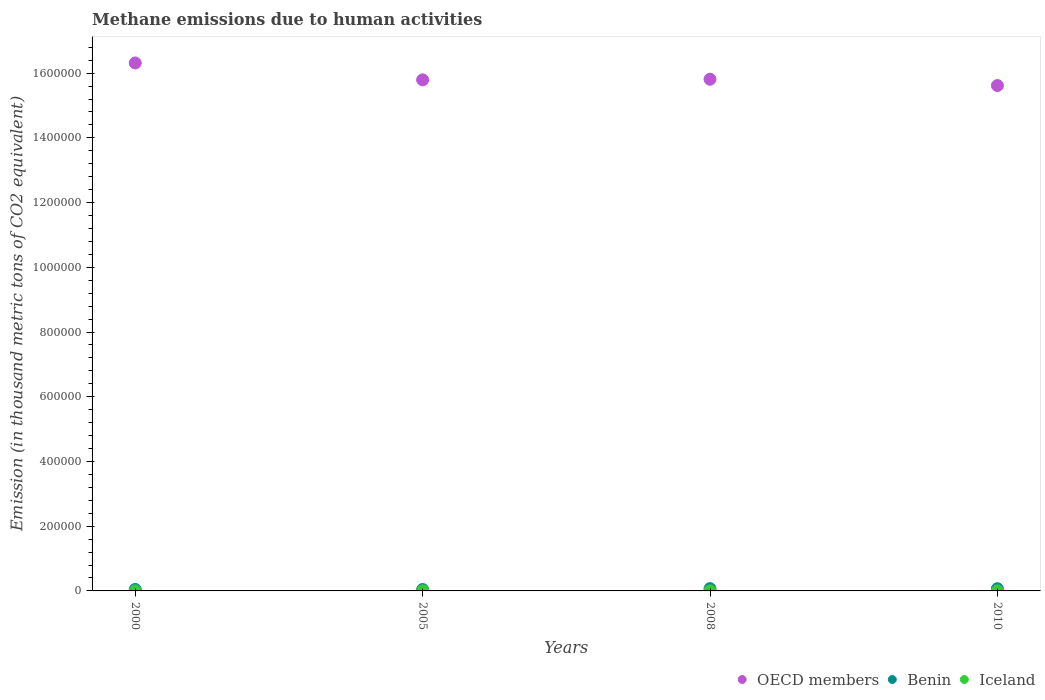Is the number of dotlines equal to the number of legend labels?
Your answer should be compact. Yes. What is the amount of methane emitted in OECD members in 2008?
Your answer should be compact. 1.58e+06. Across all years, what is the maximum amount of methane emitted in OECD members?
Your answer should be compact. 1.63e+06. Across all years, what is the minimum amount of methane emitted in OECD members?
Provide a succinct answer. 1.56e+06. In which year was the amount of methane emitted in OECD members minimum?
Provide a succinct answer. 2010. What is the total amount of methane emitted in Iceland in the graph?
Provide a succinct answer. 1422.9. What is the difference between the amount of methane emitted in Iceland in 2005 and that in 2008?
Give a very brief answer. -31.3. What is the difference between the amount of methane emitted in OECD members in 2005 and the amount of methane emitted in Benin in 2010?
Ensure brevity in your answer.  1.57e+06. What is the average amount of methane emitted in Iceland per year?
Make the answer very short. 355.72. In the year 2010, what is the difference between the amount of methane emitted in Iceland and amount of methane emitted in Benin?
Your answer should be compact. -6462.3. What is the ratio of the amount of methane emitted in OECD members in 2008 to that in 2010?
Ensure brevity in your answer.  1.01. Is the amount of methane emitted in OECD members in 2008 less than that in 2010?
Offer a very short reply. No. What is the difference between the highest and the second highest amount of methane emitted in OECD members?
Provide a succinct answer. 5.02e+04. What is the difference between the highest and the lowest amount of methane emitted in Iceland?
Provide a short and direct response. 47.4. Is the sum of the amount of methane emitted in Benin in 2000 and 2005 greater than the maximum amount of methane emitted in OECD members across all years?
Your answer should be very brief. No. Does the amount of methane emitted in OECD members monotonically increase over the years?
Make the answer very short. No. Is the amount of methane emitted in Iceland strictly greater than the amount of methane emitted in Benin over the years?
Offer a terse response. No. How many dotlines are there?
Provide a succinct answer. 3. What is the difference between two consecutive major ticks on the Y-axis?
Make the answer very short. 2.00e+05. Does the graph contain grids?
Offer a terse response. No. How many legend labels are there?
Offer a very short reply. 3. What is the title of the graph?
Your answer should be very brief. Methane emissions due to human activities. What is the label or title of the Y-axis?
Your answer should be very brief. Emission (in thousand metric tons of CO2 equivalent). What is the Emission (in thousand metric tons of CO2 equivalent) in OECD members in 2000?
Offer a very short reply. 1.63e+06. What is the Emission (in thousand metric tons of CO2 equivalent) in Benin in 2000?
Give a very brief answer. 4503.8. What is the Emission (in thousand metric tons of CO2 equivalent) in Iceland in 2000?
Ensure brevity in your answer.  336.5. What is the Emission (in thousand metric tons of CO2 equivalent) in OECD members in 2005?
Give a very brief answer. 1.58e+06. What is the Emission (in thousand metric tons of CO2 equivalent) of Benin in 2005?
Provide a succinct answer. 4377.3. What is the Emission (in thousand metric tons of CO2 equivalent) in Iceland in 2005?
Your response must be concise. 335.9. What is the Emission (in thousand metric tons of CO2 equivalent) of OECD members in 2008?
Offer a very short reply. 1.58e+06. What is the Emission (in thousand metric tons of CO2 equivalent) in Benin in 2008?
Ensure brevity in your answer.  7086.6. What is the Emission (in thousand metric tons of CO2 equivalent) in Iceland in 2008?
Your answer should be compact. 367.2. What is the Emission (in thousand metric tons of CO2 equivalent) in OECD members in 2010?
Your answer should be compact. 1.56e+06. What is the Emission (in thousand metric tons of CO2 equivalent) in Benin in 2010?
Make the answer very short. 6845.6. What is the Emission (in thousand metric tons of CO2 equivalent) of Iceland in 2010?
Offer a terse response. 383.3. Across all years, what is the maximum Emission (in thousand metric tons of CO2 equivalent) in OECD members?
Provide a short and direct response. 1.63e+06. Across all years, what is the maximum Emission (in thousand metric tons of CO2 equivalent) of Benin?
Your answer should be compact. 7086.6. Across all years, what is the maximum Emission (in thousand metric tons of CO2 equivalent) in Iceland?
Give a very brief answer. 383.3. Across all years, what is the minimum Emission (in thousand metric tons of CO2 equivalent) of OECD members?
Offer a very short reply. 1.56e+06. Across all years, what is the minimum Emission (in thousand metric tons of CO2 equivalent) in Benin?
Keep it short and to the point. 4377.3. Across all years, what is the minimum Emission (in thousand metric tons of CO2 equivalent) in Iceland?
Provide a short and direct response. 335.9. What is the total Emission (in thousand metric tons of CO2 equivalent) of OECD members in the graph?
Keep it short and to the point. 6.35e+06. What is the total Emission (in thousand metric tons of CO2 equivalent) of Benin in the graph?
Offer a terse response. 2.28e+04. What is the total Emission (in thousand metric tons of CO2 equivalent) of Iceland in the graph?
Your answer should be compact. 1422.9. What is the difference between the Emission (in thousand metric tons of CO2 equivalent) in OECD members in 2000 and that in 2005?
Offer a terse response. 5.21e+04. What is the difference between the Emission (in thousand metric tons of CO2 equivalent) of Benin in 2000 and that in 2005?
Provide a short and direct response. 126.5. What is the difference between the Emission (in thousand metric tons of CO2 equivalent) in OECD members in 2000 and that in 2008?
Your answer should be very brief. 5.02e+04. What is the difference between the Emission (in thousand metric tons of CO2 equivalent) of Benin in 2000 and that in 2008?
Make the answer very short. -2582.8. What is the difference between the Emission (in thousand metric tons of CO2 equivalent) in Iceland in 2000 and that in 2008?
Your answer should be very brief. -30.7. What is the difference between the Emission (in thousand metric tons of CO2 equivalent) in OECD members in 2000 and that in 2010?
Keep it short and to the point. 6.98e+04. What is the difference between the Emission (in thousand metric tons of CO2 equivalent) of Benin in 2000 and that in 2010?
Ensure brevity in your answer.  -2341.8. What is the difference between the Emission (in thousand metric tons of CO2 equivalent) in Iceland in 2000 and that in 2010?
Offer a very short reply. -46.8. What is the difference between the Emission (in thousand metric tons of CO2 equivalent) in OECD members in 2005 and that in 2008?
Provide a short and direct response. -1871.6. What is the difference between the Emission (in thousand metric tons of CO2 equivalent) in Benin in 2005 and that in 2008?
Your response must be concise. -2709.3. What is the difference between the Emission (in thousand metric tons of CO2 equivalent) of Iceland in 2005 and that in 2008?
Your answer should be compact. -31.3. What is the difference between the Emission (in thousand metric tons of CO2 equivalent) of OECD members in 2005 and that in 2010?
Provide a succinct answer. 1.77e+04. What is the difference between the Emission (in thousand metric tons of CO2 equivalent) of Benin in 2005 and that in 2010?
Offer a very short reply. -2468.3. What is the difference between the Emission (in thousand metric tons of CO2 equivalent) in Iceland in 2005 and that in 2010?
Give a very brief answer. -47.4. What is the difference between the Emission (in thousand metric tons of CO2 equivalent) of OECD members in 2008 and that in 2010?
Ensure brevity in your answer.  1.96e+04. What is the difference between the Emission (in thousand metric tons of CO2 equivalent) in Benin in 2008 and that in 2010?
Your answer should be very brief. 241. What is the difference between the Emission (in thousand metric tons of CO2 equivalent) in Iceland in 2008 and that in 2010?
Make the answer very short. -16.1. What is the difference between the Emission (in thousand metric tons of CO2 equivalent) in OECD members in 2000 and the Emission (in thousand metric tons of CO2 equivalent) in Benin in 2005?
Give a very brief answer. 1.63e+06. What is the difference between the Emission (in thousand metric tons of CO2 equivalent) in OECD members in 2000 and the Emission (in thousand metric tons of CO2 equivalent) in Iceland in 2005?
Keep it short and to the point. 1.63e+06. What is the difference between the Emission (in thousand metric tons of CO2 equivalent) in Benin in 2000 and the Emission (in thousand metric tons of CO2 equivalent) in Iceland in 2005?
Offer a very short reply. 4167.9. What is the difference between the Emission (in thousand metric tons of CO2 equivalent) of OECD members in 2000 and the Emission (in thousand metric tons of CO2 equivalent) of Benin in 2008?
Your response must be concise. 1.62e+06. What is the difference between the Emission (in thousand metric tons of CO2 equivalent) of OECD members in 2000 and the Emission (in thousand metric tons of CO2 equivalent) of Iceland in 2008?
Offer a terse response. 1.63e+06. What is the difference between the Emission (in thousand metric tons of CO2 equivalent) of Benin in 2000 and the Emission (in thousand metric tons of CO2 equivalent) of Iceland in 2008?
Provide a short and direct response. 4136.6. What is the difference between the Emission (in thousand metric tons of CO2 equivalent) in OECD members in 2000 and the Emission (in thousand metric tons of CO2 equivalent) in Benin in 2010?
Offer a very short reply. 1.62e+06. What is the difference between the Emission (in thousand metric tons of CO2 equivalent) of OECD members in 2000 and the Emission (in thousand metric tons of CO2 equivalent) of Iceland in 2010?
Your response must be concise. 1.63e+06. What is the difference between the Emission (in thousand metric tons of CO2 equivalent) in Benin in 2000 and the Emission (in thousand metric tons of CO2 equivalent) in Iceland in 2010?
Give a very brief answer. 4120.5. What is the difference between the Emission (in thousand metric tons of CO2 equivalent) in OECD members in 2005 and the Emission (in thousand metric tons of CO2 equivalent) in Benin in 2008?
Keep it short and to the point. 1.57e+06. What is the difference between the Emission (in thousand metric tons of CO2 equivalent) of OECD members in 2005 and the Emission (in thousand metric tons of CO2 equivalent) of Iceland in 2008?
Offer a terse response. 1.58e+06. What is the difference between the Emission (in thousand metric tons of CO2 equivalent) of Benin in 2005 and the Emission (in thousand metric tons of CO2 equivalent) of Iceland in 2008?
Your response must be concise. 4010.1. What is the difference between the Emission (in thousand metric tons of CO2 equivalent) of OECD members in 2005 and the Emission (in thousand metric tons of CO2 equivalent) of Benin in 2010?
Your answer should be very brief. 1.57e+06. What is the difference between the Emission (in thousand metric tons of CO2 equivalent) in OECD members in 2005 and the Emission (in thousand metric tons of CO2 equivalent) in Iceland in 2010?
Offer a terse response. 1.58e+06. What is the difference between the Emission (in thousand metric tons of CO2 equivalent) of Benin in 2005 and the Emission (in thousand metric tons of CO2 equivalent) of Iceland in 2010?
Provide a succinct answer. 3994. What is the difference between the Emission (in thousand metric tons of CO2 equivalent) in OECD members in 2008 and the Emission (in thousand metric tons of CO2 equivalent) in Benin in 2010?
Your answer should be very brief. 1.57e+06. What is the difference between the Emission (in thousand metric tons of CO2 equivalent) of OECD members in 2008 and the Emission (in thousand metric tons of CO2 equivalent) of Iceland in 2010?
Your answer should be compact. 1.58e+06. What is the difference between the Emission (in thousand metric tons of CO2 equivalent) in Benin in 2008 and the Emission (in thousand metric tons of CO2 equivalent) in Iceland in 2010?
Give a very brief answer. 6703.3. What is the average Emission (in thousand metric tons of CO2 equivalent) of OECD members per year?
Provide a succinct answer. 1.59e+06. What is the average Emission (in thousand metric tons of CO2 equivalent) of Benin per year?
Ensure brevity in your answer.  5703.32. What is the average Emission (in thousand metric tons of CO2 equivalent) in Iceland per year?
Provide a short and direct response. 355.73. In the year 2000, what is the difference between the Emission (in thousand metric tons of CO2 equivalent) of OECD members and Emission (in thousand metric tons of CO2 equivalent) of Benin?
Offer a very short reply. 1.63e+06. In the year 2000, what is the difference between the Emission (in thousand metric tons of CO2 equivalent) of OECD members and Emission (in thousand metric tons of CO2 equivalent) of Iceland?
Ensure brevity in your answer.  1.63e+06. In the year 2000, what is the difference between the Emission (in thousand metric tons of CO2 equivalent) of Benin and Emission (in thousand metric tons of CO2 equivalent) of Iceland?
Provide a succinct answer. 4167.3. In the year 2005, what is the difference between the Emission (in thousand metric tons of CO2 equivalent) of OECD members and Emission (in thousand metric tons of CO2 equivalent) of Benin?
Offer a terse response. 1.57e+06. In the year 2005, what is the difference between the Emission (in thousand metric tons of CO2 equivalent) of OECD members and Emission (in thousand metric tons of CO2 equivalent) of Iceland?
Ensure brevity in your answer.  1.58e+06. In the year 2005, what is the difference between the Emission (in thousand metric tons of CO2 equivalent) of Benin and Emission (in thousand metric tons of CO2 equivalent) of Iceland?
Your answer should be very brief. 4041.4. In the year 2008, what is the difference between the Emission (in thousand metric tons of CO2 equivalent) of OECD members and Emission (in thousand metric tons of CO2 equivalent) of Benin?
Your answer should be compact. 1.57e+06. In the year 2008, what is the difference between the Emission (in thousand metric tons of CO2 equivalent) of OECD members and Emission (in thousand metric tons of CO2 equivalent) of Iceland?
Ensure brevity in your answer.  1.58e+06. In the year 2008, what is the difference between the Emission (in thousand metric tons of CO2 equivalent) of Benin and Emission (in thousand metric tons of CO2 equivalent) of Iceland?
Keep it short and to the point. 6719.4. In the year 2010, what is the difference between the Emission (in thousand metric tons of CO2 equivalent) in OECD members and Emission (in thousand metric tons of CO2 equivalent) in Benin?
Your answer should be very brief. 1.55e+06. In the year 2010, what is the difference between the Emission (in thousand metric tons of CO2 equivalent) of OECD members and Emission (in thousand metric tons of CO2 equivalent) of Iceland?
Provide a succinct answer. 1.56e+06. In the year 2010, what is the difference between the Emission (in thousand metric tons of CO2 equivalent) in Benin and Emission (in thousand metric tons of CO2 equivalent) in Iceland?
Offer a very short reply. 6462.3. What is the ratio of the Emission (in thousand metric tons of CO2 equivalent) in OECD members in 2000 to that in 2005?
Offer a very short reply. 1.03. What is the ratio of the Emission (in thousand metric tons of CO2 equivalent) in Benin in 2000 to that in 2005?
Your answer should be compact. 1.03. What is the ratio of the Emission (in thousand metric tons of CO2 equivalent) in OECD members in 2000 to that in 2008?
Your answer should be compact. 1.03. What is the ratio of the Emission (in thousand metric tons of CO2 equivalent) in Benin in 2000 to that in 2008?
Make the answer very short. 0.64. What is the ratio of the Emission (in thousand metric tons of CO2 equivalent) of Iceland in 2000 to that in 2008?
Provide a short and direct response. 0.92. What is the ratio of the Emission (in thousand metric tons of CO2 equivalent) of OECD members in 2000 to that in 2010?
Offer a terse response. 1.04. What is the ratio of the Emission (in thousand metric tons of CO2 equivalent) of Benin in 2000 to that in 2010?
Keep it short and to the point. 0.66. What is the ratio of the Emission (in thousand metric tons of CO2 equivalent) of Iceland in 2000 to that in 2010?
Provide a short and direct response. 0.88. What is the ratio of the Emission (in thousand metric tons of CO2 equivalent) in Benin in 2005 to that in 2008?
Provide a succinct answer. 0.62. What is the ratio of the Emission (in thousand metric tons of CO2 equivalent) in Iceland in 2005 to that in 2008?
Offer a very short reply. 0.91. What is the ratio of the Emission (in thousand metric tons of CO2 equivalent) in OECD members in 2005 to that in 2010?
Keep it short and to the point. 1.01. What is the ratio of the Emission (in thousand metric tons of CO2 equivalent) in Benin in 2005 to that in 2010?
Your answer should be very brief. 0.64. What is the ratio of the Emission (in thousand metric tons of CO2 equivalent) in Iceland in 2005 to that in 2010?
Offer a terse response. 0.88. What is the ratio of the Emission (in thousand metric tons of CO2 equivalent) of OECD members in 2008 to that in 2010?
Provide a succinct answer. 1.01. What is the ratio of the Emission (in thousand metric tons of CO2 equivalent) of Benin in 2008 to that in 2010?
Make the answer very short. 1.04. What is the ratio of the Emission (in thousand metric tons of CO2 equivalent) of Iceland in 2008 to that in 2010?
Your response must be concise. 0.96. What is the difference between the highest and the second highest Emission (in thousand metric tons of CO2 equivalent) of OECD members?
Keep it short and to the point. 5.02e+04. What is the difference between the highest and the second highest Emission (in thousand metric tons of CO2 equivalent) of Benin?
Give a very brief answer. 241. What is the difference between the highest and the lowest Emission (in thousand metric tons of CO2 equivalent) in OECD members?
Keep it short and to the point. 6.98e+04. What is the difference between the highest and the lowest Emission (in thousand metric tons of CO2 equivalent) of Benin?
Offer a terse response. 2709.3. What is the difference between the highest and the lowest Emission (in thousand metric tons of CO2 equivalent) of Iceland?
Provide a short and direct response. 47.4. 